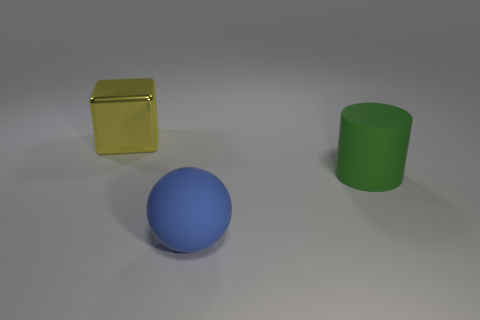What purpose might these objects serve in a real-world setting? In a real-world setting, these objects could be simplistic representations of household items: the block might be a container or canister, the cylinder could be a cup or storage holder, and the sphere could be a decorative ball or a child's toy. 